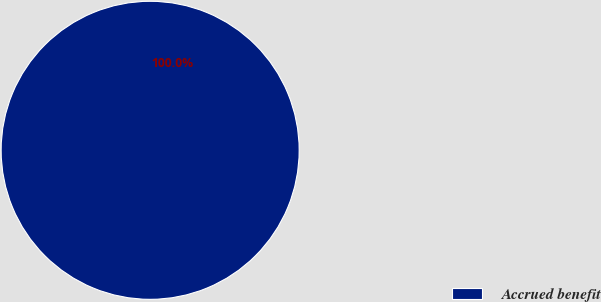<chart> <loc_0><loc_0><loc_500><loc_500><pie_chart><fcel>Accrued benefit<nl><fcel>100.0%<nl></chart> 